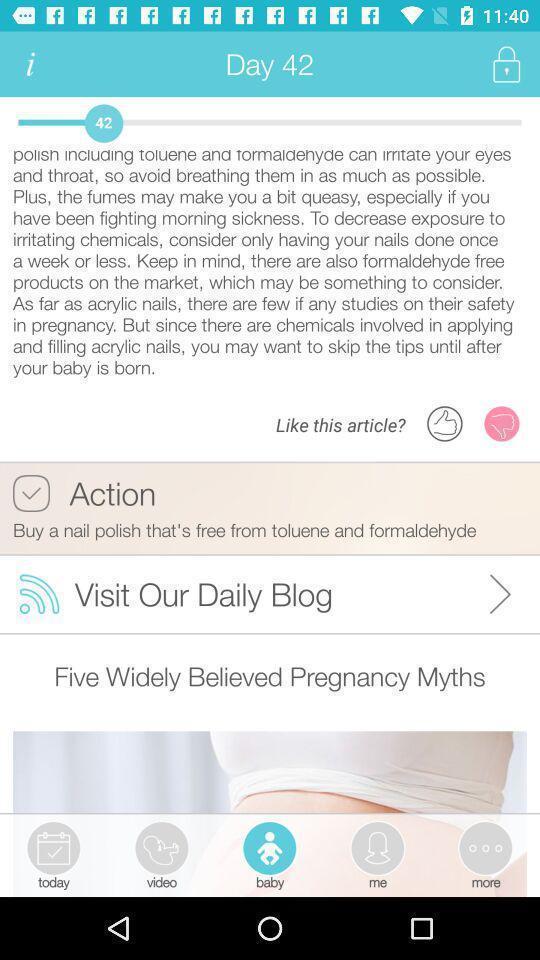Describe the key features of this screenshot. Page displaying pregnancy care application. 